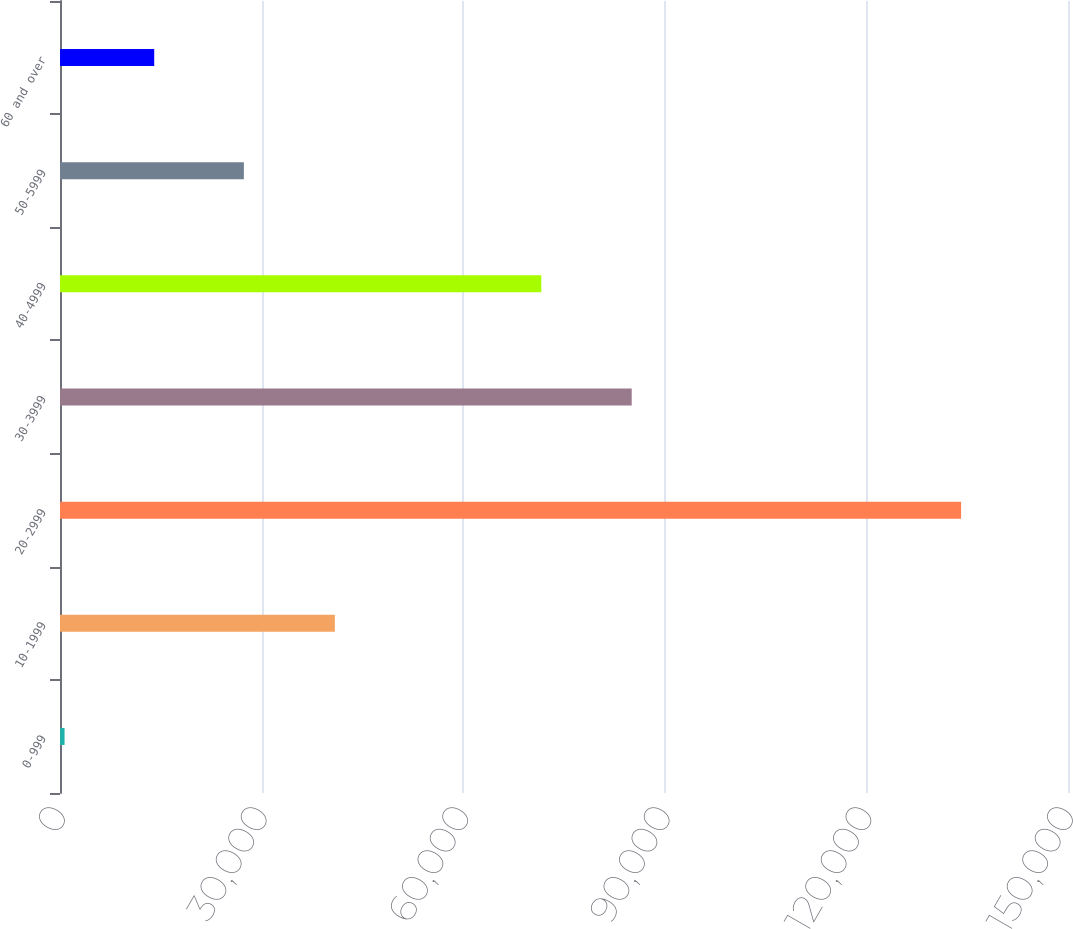Convert chart to OTSL. <chart><loc_0><loc_0><loc_500><loc_500><bar_chart><fcel>0-999<fcel>10-1999<fcel>20-2999<fcel>30-3999<fcel>40-4999<fcel>50-5999<fcel>60 and over<nl><fcel>678<fcel>40902<fcel>134093<fcel>85074<fcel>71619<fcel>27361<fcel>14019.5<nl></chart> 